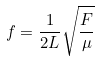<formula> <loc_0><loc_0><loc_500><loc_500>f = \frac { 1 } { 2 L } \sqrt { \frac { F } { \mu } }</formula> 